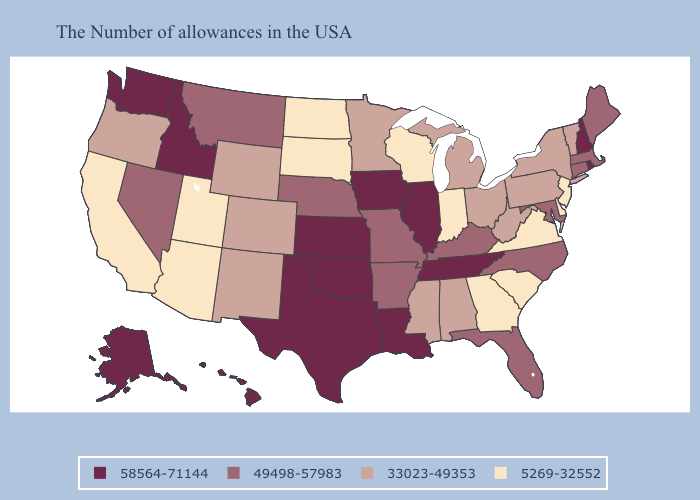Does the map have missing data?
Be succinct. No. Does Illinois have a higher value than Washington?
Answer briefly. No. What is the value of Montana?
Be succinct. 49498-57983. Among the states that border Oregon , which have the lowest value?
Be succinct. California. Name the states that have a value in the range 58564-71144?
Be succinct. Rhode Island, New Hampshire, Tennessee, Illinois, Louisiana, Iowa, Kansas, Oklahoma, Texas, Idaho, Washington, Alaska, Hawaii. What is the value of Colorado?
Quick response, please. 33023-49353. What is the value of Pennsylvania?
Be succinct. 33023-49353. Name the states that have a value in the range 49498-57983?
Write a very short answer. Maine, Massachusetts, Connecticut, Maryland, North Carolina, Florida, Kentucky, Missouri, Arkansas, Nebraska, Montana, Nevada. What is the value of Utah?
Concise answer only. 5269-32552. Which states have the lowest value in the MidWest?
Short answer required. Indiana, Wisconsin, South Dakota, North Dakota. What is the value of Utah?
Quick response, please. 5269-32552. What is the value of New York?
Give a very brief answer. 33023-49353. What is the value of Kentucky?
Write a very short answer. 49498-57983. Does North Dakota have the lowest value in the USA?
Be succinct. Yes. Does North Dakota have the lowest value in the USA?
Short answer required. Yes. 